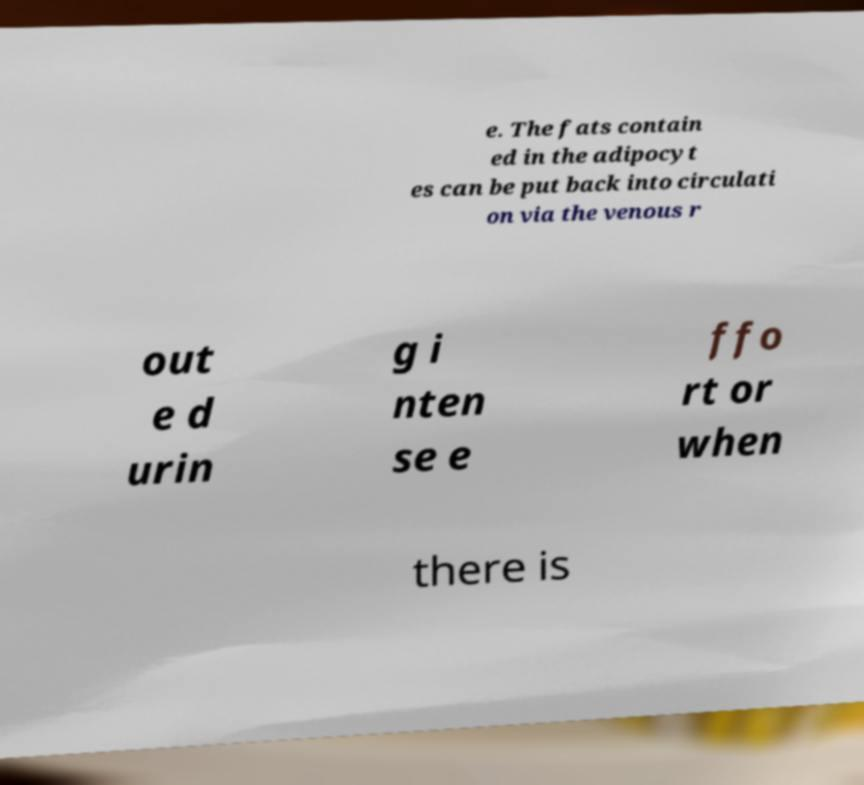There's text embedded in this image that I need extracted. Can you transcribe it verbatim? e. The fats contain ed in the adipocyt es can be put back into circulati on via the venous r out e d urin g i nten se e ffo rt or when there is 